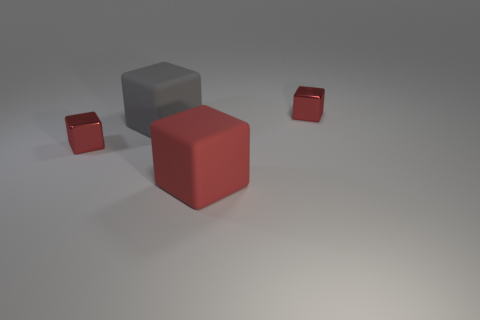Subtract all gray spheres. How many red cubes are left? 3 Subtract all gray cubes. How many cubes are left? 3 Subtract all big red cubes. How many cubes are left? 3 Subtract all green blocks. Subtract all blue spheres. How many blocks are left? 4 Add 1 large rubber things. How many objects exist? 5 Subtract all small green cylinders. Subtract all gray blocks. How many objects are left? 3 Add 3 small red shiny blocks. How many small red shiny blocks are left? 5 Add 2 rubber blocks. How many rubber blocks exist? 4 Subtract 0 brown blocks. How many objects are left? 4 